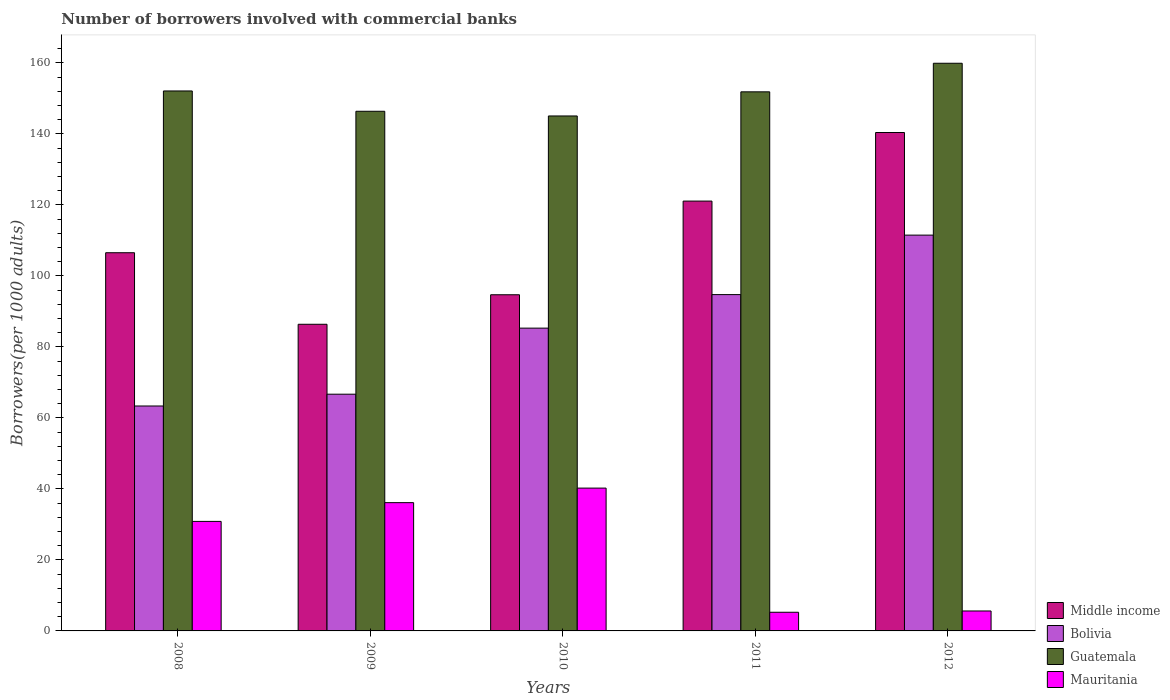Are the number of bars per tick equal to the number of legend labels?
Keep it short and to the point. Yes. Are the number of bars on each tick of the X-axis equal?
Your answer should be compact. Yes. How many bars are there on the 3rd tick from the left?
Your answer should be very brief. 4. How many bars are there on the 1st tick from the right?
Your answer should be very brief. 4. What is the label of the 2nd group of bars from the left?
Your response must be concise. 2009. What is the number of borrowers involved with commercial banks in Bolivia in 2009?
Offer a terse response. 66.68. Across all years, what is the maximum number of borrowers involved with commercial banks in Bolivia?
Provide a succinct answer. 111.49. Across all years, what is the minimum number of borrowers involved with commercial banks in Mauritania?
Give a very brief answer. 5.26. In which year was the number of borrowers involved with commercial banks in Bolivia maximum?
Ensure brevity in your answer.  2012. In which year was the number of borrowers involved with commercial banks in Middle income minimum?
Give a very brief answer. 2009. What is the total number of borrowers involved with commercial banks in Middle income in the graph?
Give a very brief answer. 549.05. What is the difference between the number of borrowers involved with commercial banks in Mauritania in 2009 and that in 2011?
Your response must be concise. 30.88. What is the difference between the number of borrowers involved with commercial banks in Middle income in 2008 and the number of borrowers involved with commercial banks in Mauritania in 2012?
Your answer should be compact. 100.91. What is the average number of borrowers involved with commercial banks in Bolivia per year?
Your answer should be compact. 84.31. In the year 2008, what is the difference between the number of borrowers involved with commercial banks in Guatemala and number of borrowers involved with commercial banks in Mauritania?
Make the answer very short. 121.25. What is the ratio of the number of borrowers involved with commercial banks in Guatemala in 2009 to that in 2010?
Provide a succinct answer. 1.01. What is the difference between the highest and the second highest number of borrowers involved with commercial banks in Middle income?
Keep it short and to the point. 19.32. What is the difference between the highest and the lowest number of borrowers involved with commercial banks in Bolivia?
Your response must be concise. 48.13. In how many years, is the number of borrowers involved with commercial banks in Guatemala greater than the average number of borrowers involved with commercial banks in Guatemala taken over all years?
Your answer should be very brief. 3. What does the 3rd bar from the left in 2012 represents?
Keep it short and to the point. Guatemala. What does the 1st bar from the right in 2012 represents?
Offer a terse response. Mauritania. What is the difference between two consecutive major ticks on the Y-axis?
Your answer should be very brief. 20. Does the graph contain grids?
Your answer should be compact. No. Where does the legend appear in the graph?
Give a very brief answer. Bottom right. How are the legend labels stacked?
Provide a succinct answer. Vertical. What is the title of the graph?
Provide a succinct answer. Number of borrowers involved with commercial banks. What is the label or title of the Y-axis?
Offer a very short reply. Borrowers(per 1000 adults). What is the Borrowers(per 1000 adults) in Middle income in 2008?
Keep it short and to the point. 106.53. What is the Borrowers(per 1000 adults) in Bolivia in 2008?
Your answer should be compact. 63.36. What is the Borrowers(per 1000 adults) in Guatemala in 2008?
Provide a short and direct response. 152.09. What is the Borrowers(per 1000 adults) in Mauritania in 2008?
Your response must be concise. 30.85. What is the Borrowers(per 1000 adults) in Middle income in 2009?
Your answer should be very brief. 86.38. What is the Borrowers(per 1000 adults) of Bolivia in 2009?
Ensure brevity in your answer.  66.68. What is the Borrowers(per 1000 adults) in Guatemala in 2009?
Provide a succinct answer. 146.37. What is the Borrowers(per 1000 adults) of Mauritania in 2009?
Your answer should be compact. 36.13. What is the Borrowers(per 1000 adults) in Middle income in 2010?
Give a very brief answer. 94.69. What is the Borrowers(per 1000 adults) in Bolivia in 2010?
Your answer should be compact. 85.29. What is the Borrowers(per 1000 adults) in Guatemala in 2010?
Give a very brief answer. 145.05. What is the Borrowers(per 1000 adults) of Mauritania in 2010?
Give a very brief answer. 40.23. What is the Borrowers(per 1000 adults) of Middle income in 2011?
Offer a very short reply. 121.07. What is the Borrowers(per 1000 adults) of Bolivia in 2011?
Provide a short and direct response. 94.73. What is the Borrowers(per 1000 adults) of Guatemala in 2011?
Provide a short and direct response. 151.85. What is the Borrowers(per 1000 adults) in Mauritania in 2011?
Your response must be concise. 5.26. What is the Borrowers(per 1000 adults) of Middle income in 2012?
Give a very brief answer. 140.39. What is the Borrowers(per 1000 adults) in Bolivia in 2012?
Keep it short and to the point. 111.49. What is the Borrowers(per 1000 adults) in Guatemala in 2012?
Your answer should be very brief. 159.9. What is the Borrowers(per 1000 adults) in Mauritania in 2012?
Your answer should be very brief. 5.62. Across all years, what is the maximum Borrowers(per 1000 adults) in Middle income?
Your answer should be compact. 140.39. Across all years, what is the maximum Borrowers(per 1000 adults) of Bolivia?
Your answer should be very brief. 111.49. Across all years, what is the maximum Borrowers(per 1000 adults) in Guatemala?
Offer a terse response. 159.9. Across all years, what is the maximum Borrowers(per 1000 adults) in Mauritania?
Your answer should be compact. 40.23. Across all years, what is the minimum Borrowers(per 1000 adults) of Middle income?
Your answer should be compact. 86.38. Across all years, what is the minimum Borrowers(per 1000 adults) in Bolivia?
Ensure brevity in your answer.  63.36. Across all years, what is the minimum Borrowers(per 1000 adults) of Guatemala?
Your response must be concise. 145.05. Across all years, what is the minimum Borrowers(per 1000 adults) of Mauritania?
Provide a succinct answer. 5.26. What is the total Borrowers(per 1000 adults) in Middle income in the graph?
Offer a very short reply. 549.05. What is the total Borrowers(per 1000 adults) of Bolivia in the graph?
Your response must be concise. 421.54. What is the total Borrowers(per 1000 adults) in Guatemala in the graph?
Provide a short and direct response. 755.26. What is the total Borrowers(per 1000 adults) in Mauritania in the graph?
Your answer should be compact. 118.08. What is the difference between the Borrowers(per 1000 adults) of Middle income in 2008 and that in 2009?
Ensure brevity in your answer.  20.15. What is the difference between the Borrowers(per 1000 adults) of Bolivia in 2008 and that in 2009?
Offer a very short reply. -3.32. What is the difference between the Borrowers(per 1000 adults) of Guatemala in 2008 and that in 2009?
Ensure brevity in your answer.  5.72. What is the difference between the Borrowers(per 1000 adults) in Mauritania in 2008 and that in 2009?
Offer a terse response. -5.28. What is the difference between the Borrowers(per 1000 adults) in Middle income in 2008 and that in 2010?
Your response must be concise. 11.84. What is the difference between the Borrowers(per 1000 adults) in Bolivia in 2008 and that in 2010?
Give a very brief answer. -21.93. What is the difference between the Borrowers(per 1000 adults) of Guatemala in 2008 and that in 2010?
Your answer should be very brief. 7.04. What is the difference between the Borrowers(per 1000 adults) in Mauritania in 2008 and that in 2010?
Your response must be concise. -9.38. What is the difference between the Borrowers(per 1000 adults) in Middle income in 2008 and that in 2011?
Make the answer very short. -14.55. What is the difference between the Borrowers(per 1000 adults) in Bolivia in 2008 and that in 2011?
Offer a very short reply. -31.37. What is the difference between the Borrowers(per 1000 adults) of Guatemala in 2008 and that in 2011?
Your answer should be very brief. 0.25. What is the difference between the Borrowers(per 1000 adults) of Mauritania in 2008 and that in 2011?
Make the answer very short. 25.59. What is the difference between the Borrowers(per 1000 adults) in Middle income in 2008 and that in 2012?
Keep it short and to the point. -33.86. What is the difference between the Borrowers(per 1000 adults) in Bolivia in 2008 and that in 2012?
Your response must be concise. -48.13. What is the difference between the Borrowers(per 1000 adults) in Guatemala in 2008 and that in 2012?
Offer a terse response. -7.8. What is the difference between the Borrowers(per 1000 adults) in Mauritania in 2008 and that in 2012?
Give a very brief answer. 25.23. What is the difference between the Borrowers(per 1000 adults) of Middle income in 2009 and that in 2010?
Provide a short and direct response. -8.31. What is the difference between the Borrowers(per 1000 adults) of Bolivia in 2009 and that in 2010?
Offer a very short reply. -18.61. What is the difference between the Borrowers(per 1000 adults) of Guatemala in 2009 and that in 2010?
Provide a short and direct response. 1.32. What is the difference between the Borrowers(per 1000 adults) of Mauritania in 2009 and that in 2010?
Give a very brief answer. -4.1. What is the difference between the Borrowers(per 1000 adults) in Middle income in 2009 and that in 2011?
Your answer should be very brief. -34.7. What is the difference between the Borrowers(per 1000 adults) in Bolivia in 2009 and that in 2011?
Ensure brevity in your answer.  -28.05. What is the difference between the Borrowers(per 1000 adults) in Guatemala in 2009 and that in 2011?
Your answer should be very brief. -5.48. What is the difference between the Borrowers(per 1000 adults) in Mauritania in 2009 and that in 2011?
Offer a terse response. 30.88. What is the difference between the Borrowers(per 1000 adults) of Middle income in 2009 and that in 2012?
Offer a very short reply. -54.02. What is the difference between the Borrowers(per 1000 adults) in Bolivia in 2009 and that in 2012?
Give a very brief answer. -44.81. What is the difference between the Borrowers(per 1000 adults) of Guatemala in 2009 and that in 2012?
Ensure brevity in your answer.  -13.53. What is the difference between the Borrowers(per 1000 adults) of Mauritania in 2009 and that in 2012?
Keep it short and to the point. 30.51. What is the difference between the Borrowers(per 1000 adults) in Middle income in 2010 and that in 2011?
Offer a very short reply. -26.38. What is the difference between the Borrowers(per 1000 adults) in Bolivia in 2010 and that in 2011?
Keep it short and to the point. -9.45. What is the difference between the Borrowers(per 1000 adults) of Guatemala in 2010 and that in 2011?
Keep it short and to the point. -6.8. What is the difference between the Borrowers(per 1000 adults) of Mauritania in 2010 and that in 2011?
Your response must be concise. 34.97. What is the difference between the Borrowers(per 1000 adults) in Middle income in 2010 and that in 2012?
Your answer should be compact. -45.7. What is the difference between the Borrowers(per 1000 adults) of Bolivia in 2010 and that in 2012?
Give a very brief answer. -26.2. What is the difference between the Borrowers(per 1000 adults) in Guatemala in 2010 and that in 2012?
Your answer should be compact. -14.85. What is the difference between the Borrowers(per 1000 adults) of Mauritania in 2010 and that in 2012?
Your answer should be compact. 34.61. What is the difference between the Borrowers(per 1000 adults) of Middle income in 2011 and that in 2012?
Offer a terse response. -19.32. What is the difference between the Borrowers(per 1000 adults) of Bolivia in 2011 and that in 2012?
Ensure brevity in your answer.  -16.75. What is the difference between the Borrowers(per 1000 adults) in Guatemala in 2011 and that in 2012?
Make the answer very short. -8.05. What is the difference between the Borrowers(per 1000 adults) in Mauritania in 2011 and that in 2012?
Give a very brief answer. -0.36. What is the difference between the Borrowers(per 1000 adults) in Middle income in 2008 and the Borrowers(per 1000 adults) in Bolivia in 2009?
Offer a terse response. 39.85. What is the difference between the Borrowers(per 1000 adults) in Middle income in 2008 and the Borrowers(per 1000 adults) in Guatemala in 2009?
Your answer should be very brief. -39.85. What is the difference between the Borrowers(per 1000 adults) in Middle income in 2008 and the Borrowers(per 1000 adults) in Mauritania in 2009?
Your answer should be very brief. 70.39. What is the difference between the Borrowers(per 1000 adults) in Bolivia in 2008 and the Borrowers(per 1000 adults) in Guatemala in 2009?
Give a very brief answer. -83.01. What is the difference between the Borrowers(per 1000 adults) in Bolivia in 2008 and the Borrowers(per 1000 adults) in Mauritania in 2009?
Offer a very short reply. 27.23. What is the difference between the Borrowers(per 1000 adults) of Guatemala in 2008 and the Borrowers(per 1000 adults) of Mauritania in 2009?
Give a very brief answer. 115.96. What is the difference between the Borrowers(per 1000 adults) of Middle income in 2008 and the Borrowers(per 1000 adults) of Bolivia in 2010?
Keep it short and to the point. 21.24. What is the difference between the Borrowers(per 1000 adults) in Middle income in 2008 and the Borrowers(per 1000 adults) in Guatemala in 2010?
Make the answer very short. -38.52. What is the difference between the Borrowers(per 1000 adults) in Middle income in 2008 and the Borrowers(per 1000 adults) in Mauritania in 2010?
Your response must be concise. 66.3. What is the difference between the Borrowers(per 1000 adults) of Bolivia in 2008 and the Borrowers(per 1000 adults) of Guatemala in 2010?
Offer a very short reply. -81.69. What is the difference between the Borrowers(per 1000 adults) of Bolivia in 2008 and the Borrowers(per 1000 adults) of Mauritania in 2010?
Keep it short and to the point. 23.13. What is the difference between the Borrowers(per 1000 adults) of Guatemala in 2008 and the Borrowers(per 1000 adults) of Mauritania in 2010?
Your response must be concise. 111.86. What is the difference between the Borrowers(per 1000 adults) in Middle income in 2008 and the Borrowers(per 1000 adults) in Bolivia in 2011?
Offer a terse response. 11.79. What is the difference between the Borrowers(per 1000 adults) of Middle income in 2008 and the Borrowers(per 1000 adults) of Guatemala in 2011?
Give a very brief answer. -45.32. What is the difference between the Borrowers(per 1000 adults) in Middle income in 2008 and the Borrowers(per 1000 adults) in Mauritania in 2011?
Offer a very short reply. 101.27. What is the difference between the Borrowers(per 1000 adults) of Bolivia in 2008 and the Borrowers(per 1000 adults) of Guatemala in 2011?
Provide a succinct answer. -88.49. What is the difference between the Borrowers(per 1000 adults) in Bolivia in 2008 and the Borrowers(per 1000 adults) in Mauritania in 2011?
Your answer should be very brief. 58.1. What is the difference between the Borrowers(per 1000 adults) in Guatemala in 2008 and the Borrowers(per 1000 adults) in Mauritania in 2011?
Keep it short and to the point. 146.84. What is the difference between the Borrowers(per 1000 adults) of Middle income in 2008 and the Borrowers(per 1000 adults) of Bolivia in 2012?
Your answer should be compact. -4.96. What is the difference between the Borrowers(per 1000 adults) in Middle income in 2008 and the Borrowers(per 1000 adults) in Guatemala in 2012?
Offer a very short reply. -53.37. What is the difference between the Borrowers(per 1000 adults) in Middle income in 2008 and the Borrowers(per 1000 adults) in Mauritania in 2012?
Offer a very short reply. 100.91. What is the difference between the Borrowers(per 1000 adults) in Bolivia in 2008 and the Borrowers(per 1000 adults) in Guatemala in 2012?
Offer a very short reply. -96.54. What is the difference between the Borrowers(per 1000 adults) in Bolivia in 2008 and the Borrowers(per 1000 adults) in Mauritania in 2012?
Offer a very short reply. 57.74. What is the difference between the Borrowers(per 1000 adults) of Guatemala in 2008 and the Borrowers(per 1000 adults) of Mauritania in 2012?
Offer a very short reply. 146.48. What is the difference between the Borrowers(per 1000 adults) of Middle income in 2009 and the Borrowers(per 1000 adults) of Bolivia in 2010?
Offer a terse response. 1.09. What is the difference between the Borrowers(per 1000 adults) of Middle income in 2009 and the Borrowers(per 1000 adults) of Guatemala in 2010?
Provide a succinct answer. -58.68. What is the difference between the Borrowers(per 1000 adults) of Middle income in 2009 and the Borrowers(per 1000 adults) of Mauritania in 2010?
Ensure brevity in your answer.  46.15. What is the difference between the Borrowers(per 1000 adults) in Bolivia in 2009 and the Borrowers(per 1000 adults) in Guatemala in 2010?
Offer a terse response. -78.37. What is the difference between the Borrowers(per 1000 adults) of Bolivia in 2009 and the Borrowers(per 1000 adults) of Mauritania in 2010?
Make the answer very short. 26.45. What is the difference between the Borrowers(per 1000 adults) in Guatemala in 2009 and the Borrowers(per 1000 adults) in Mauritania in 2010?
Your answer should be very brief. 106.14. What is the difference between the Borrowers(per 1000 adults) of Middle income in 2009 and the Borrowers(per 1000 adults) of Bolivia in 2011?
Ensure brevity in your answer.  -8.36. What is the difference between the Borrowers(per 1000 adults) in Middle income in 2009 and the Borrowers(per 1000 adults) in Guatemala in 2011?
Your response must be concise. -65.47. What is the difference between the Borrowers(per 1000 adults) of Middle income in 2009 and the Borrowers(per 1000 adults) of Mauritania in 2011?
Your answer should be very brief. 81.12. What is the difference between the Borrowers(per 1000 adults) of Bolivia in 2009 and the Borrowers(per 1000 adults) of Guatemala in 2011?
Ensure brevity in your answer.  -85.17. What is the difference between the Borrowers(per 1000 adults) in Bolivia in 2009 and the Borrowers(per 1000 adults) in Mauritania in 2011?
Your answer should be compact. 61.42. What is the difference between the Borrowers(per 1000 adults) of Guatemala in 2009 and the Borrowers(per 1000 adults) of Mauritania in 2011?
Keep it short and to the point. 141.11. What is the difference between the Borrowers(per 1000 adults) of Middle income in 2009 and the Borrowers(per 1000 adults) of Bolivia in 2012?
Provide a succinct answer. -25.11. What is the difference between the Borrowers(per 1000 adults) of Middle income in 2009 and the Borrowers(per 1000 adults) of Guatemala in 2012?
Keep it short and to the point. -73.52. What is the difference between the Borrowers(per 1000 adults) in Middle income in 2009 and the Borrowers(per 1000 adults) in Mauritania in 2012?
Give a very brief answer. 80.76. What is the difference between the Borrowers(per 1000 adults) of Bolivia in 2009 and the Borrowers(per 1000 adults) of Guatemala in 2012?
Make the answer very short. -93.22. What is the difference between the Borrowers(per 1000 adults) in Bolivia in 2009 and the Borrowers(per 1000 adults) in Mauritania in 2012?
Ensure brevity in your answer.  61.06. What is the difference between the Borrowers(per 1000 adults) in Guatemala in 2009 and the Borrowers(per 1000 adults) in Mauritania in 2012?
Provide a short and direct response. 140.75. What is the difference between the Borrowers(per 1000 adults) of Middle income in 2010 and the Borrowers(per 1000 adults) of Bolivia in 2011?
Give a very brief answer. -0.04. What is the difference between the Borrowers(per 1000 adults) of Middle income in 2010 and the Borrowers(per 1000 adults) of Guatemala in 2011?
Give a very brief answer. -57.16. What is the difference between the Borrowers(per 1000 adults) of Middle income in 2010 and the Borrowers(per 1000 adults) of Mauritania in 2011?
Offer a terse response. 89.43. What is the difference between the Borrowers(per 1000 adults) in Bolivia in 2010 and the Borrowers(per 1000 adults) in Guatemala in 2011?
Your answer should be very brief. -66.56. What is the difference between the Borrowers(per 1000 adults) in Bolivia in 2010 and the Borrowers(per 1000 adults) in Mauritania in 2011?
Offer a very short reply. 80.03. What is the difference between the Borrowers(per 1000 adults) in Guatemala in 2010 and the Borrowers(per 1000 adults) in Mauritania in 2011?
Provide a succinct answer. 139.79. What is the difference between the Borrowers(per 1000 adults) in Middle income in 2010 and the Borrowers(per 1000 adults) in Bolivia in 2012?
Ensure brevity in your answer.  -16.8. What is the difference between the Borrowers(per 1000 adults) in Middle income in 2010 and the Borrowers(per 1000 adults) in Guatemala in 2012?
Your answer should be very brief. -65.21. What is the difference between the Borrowers(per 1000 adults) in Middle income in 2010 and the Borrowers(per 1000 adults) in Mauritania in 2012?
Your answer should be compact. 89.07. What is the difference between the Borrowers(per 1000 adults) of Bolivia in 2010 and the Borrowers(per 1000 adults) of Guatemala in 2012?
Ensure brevity in your answer.  -74.61. What is the difference between the Borrowers(per 1000 adults) of Bolivia in 2010 and the Borrowers(per 1000 adults) of Mauritania in 2012?
Keep it short and to the point. 79.67. What is the difference between the Borrowers(per 1000 adults) in Guatemala in 2010 and the Borrowers(per 1000 adults) in Mauritania in 2012?
Offer a terse response. 139.43. What is the difference between the Borrowers(per 1000 adults) in Middle income in 2011 and the Borrowers(per 1000 adults) in Bolivia in 2012?
Give a very brief answer. 9.59. What is the difference between the Borrowers(per 1000 adults) of Middle income in 2011 and the Borrowers(per 1000 adults) of Guatemala in 2012?
Keep it short and to the point. -38.82. What is the difference between the Borrowers(per 1000 adults) of Middle income in 2011 and the Borrowers(per 1000 adults) of Mauritania in 2012?
Offer a very short reply. 115.45. What is the difference between the Borrowers(per 1000 adults) of Bolivia in 2011 and the Borrowers(per 1000 adults) of Guatemala in 2012?
Your response must be concise. -65.16. What is the difference between the Borrowers(per 1000 adults) in Bolivia in 2011 and the Borrowers(per 1000 adults) in Mauritania in 2012?
Provide a succinct answer. 89.11. What is the difference between the Borrowers(per 1000 adults) in Guatemala in 2011 and the Borrowers(per 1000 adults) in Mauritania in 2012?
Offer a terse response. 146.23. What is the average Borrowers(per 1000 adults) in Middle income per year?
Offer a terse response. 109.81. What is the average Borrowers(per 1000 adults) of Bolivia per year?
Your answer should be very brief. 84.31. What is the average Borrowers(per 1000 adults) of Guatemala per year?
Keep it short and to the point. 151.05. What is the average Borrowers(per 1000 adults) of Mauritania per year?
Your answer should be very brief. 23.62. In the year 2008, what is the difference between the Borrowers(per 1000 adults) of Middle income and Borrowers(per 1000 adults) of Bolivia?
Ensure brevity in your answer.  43.17. In the year 2008, what is the difference between the Borrowers(per 1000 adults) in Middle income and Borrowers(per 1000 adults) in Guatemala?
Your answer should be compact. -45.57. In the year 2008, what is the difference between the Borrowers(per 1000 adults) of Middle income and Borrowers(per 1000 adults) of Mauritania?
Provide a short and direct response. 75.68. In the year 2008, what is the difference between the Borrowers(per 1000 adults) in Bolivia and Borrowers(per 1000 adults) in Guatemala?
Provide a short and direct response. -88.74. In the year 2008, what is the difference between the Borrowers(per 1000 adults) of Bolivia and Borrowers(per 1000 adults) of Mauritania?
Your answer should be compact. 32.51. In the year 2008, what is the difference between the Borrowers(per 1000 adults) in Guatemala and Borrowers(per 1000 adults) in Mauritania?
Make the answer very short. 121.25. In the year 2009, what is the difference between the Borrowers(per 1000 adults) of Middle income and Borrowers(per 1000 adults) of Bolivia?
Offer a very short reply. 19.7. In the year 2009, what is the difference between the Borrowers(per 1000 adults) in Middle income and Borrowers(per 1000 adults) in Guatemala?
Provide a succinct answer. -60. In the year 2009, what is the difference between the Borrowers(per 1000 adults) in Middle income and Borrowers(per 1000 adults) in Mauritania?
Provide a succinct answer. 50.24. In the year 2009, what is the difference between the Borrowers(per 1000 adults) of Bolivia and Borrowers(per 1000 adults) of Guatemala?
Give a very brief answer. -79.69. In the year 2009, what is the difference between the Borrowers(per 1000 adults) of Bolivia and Borrowers(per 1000 adults) of Mauritania?
Make the answer very short. 30.55. In the year 2009, what is the difference between the Borrowers(per 1000 adults) of Guatemala and Borrowers(per 1000 adults) of Mauritania?
Provide a succinct answer. 110.24. In the year 2010, what is the difference between the Borrowers(per 1000 adults) of Middle income and Borrowers(per 1000 adults) of Bolivia?
Provide a short and direct response. 9.4. In the year 2010, what is the difference between the Borrowers(per 1000 adults) in Middle income and Borrowers(per 1000 adults) in Guatemala?
Your answer should be very brief. -50.36. In the year 2010, what is the difference between the Borrowers(per 1000 adults) in Middle income and Borrowers(per 1000 adults) in Mauritania?
Keep it short and to the point. 54.46. In the year 2010, what is the difference between the Borrowers(per 1000 adults) of Bolivia and Borrowers(per 1000 adults) of Guatemala?
Your response must be concise. -59.76. In the year 2010, what is the difference between the Borrowers(per 1000 adults) in Bolivia and Borrowers(per 1000 adults) in Mauritania?
Offer a very short reply. 45.06. In the year 2010, what is the difference between the Borrowers(per 1000 adults) in Guatemala and Borrowers(per 1000 adults) in Mauritania?
Offer a terse response. 104.82. In the year 2011, what is the difference between the Borrowers(per 1000 adults) in Middle income and Borrowers(per 1000 adults) in Bolivia?
Give a very brief answer. 26.34. In the year 2011, what is the difference between the Borrowers(per 1000 adults) of Middle income and Borrowers(per 1000 adults) of Guatemala?
Your answer should be compact. -30.78. In the year 2011, what is the difference between the Borrowers(per 1000 adults) in Middle income and Borrowers(per 1000 adults) in Mauritania?
Offer a terse response. 115.82. In the year 2011, what is the difference between the Borrowers(per 1000 adults) of Bolivia and Borrowers(per 1000 adults) of Guatemala?
Give a very brief answer. -57.12. In the year 2011, what is the difference between the Borrowers(per 1000 adults) in Bolivia and Borrowers(per 1000 adults) in Mauritania?
Provide a succinct answer. 89.48. In the year 2011, what is the difference between the Borrowers(per 1000 adults) in Guatemala and Borrowers(per 1000 adults) in Mauritania?
Your answer should be compact. 146.59. In the year 2012, what is the difference between the Borrowers(per 1000 adults) in Middle income and Borrowers(per 1000 adults) in Bolivia?
Make the answer very short. 28.9. In the year 2012, what is the difference between the Borrowers(per 1000 adults) of Middle income and Borrowers(per 1000 adults) of Guatemala?
Offer a terse response. -19.51. In the year 2012, what is the difference between the Borrowers(per 1000 adults) in Middle income and Borrowers(per 1000 adults) in Mauritania?
Your answer should be compact. 134.77. In the year 2012, what is the difference between the Borrowers(per 1000 adults) in Bolivia and Borrowers(per 1000 adults) in Guatemala?
Your answer should be compact. -48.41. In the year 2012, what is the difference between the Borrowers(per 1000 adults) in Bolivia and Borrowers(per 1000 adults) in Mauritania?
Keep it short and to the point. 105.87. In the year 2012, what is the difference between the Borrowers(per 1000 adults) of Guatemala and Borrowers(per 1000 adults) of Mauritania?
Offer a very short reply. 154.28. What is the ratio of the Borrowers(per 1000 adults) in Middle income in 2008 to that in 2009?
Your answer should be very brief. 1.23. What is the ratio of the Borrowers(per 1000 adults) in Bolivia in 2008 to that in 2009?
Provide a short and direct response. 0.95. What is the ratio of the Borrowers(per 1000 adults) of Guatemala in 2008 to that in 2009?
Provide a short and direct response. 1.04. What is the ratio of the Borrowers(per 1000 adults) of Mauritania in 2008 to that in 2009?
Ensure brevity in your answer.  0.85. What is the ratio of the Borrowers(per 1000 adults) in Middle income in 2008 to that in 2010?
Offer a terse response. 1.12. What is the ratio of the Borrowers(per 1000 adults) in Bolivia in 2008 to that in 2010?
Ensure brevity in your answer.  0.74. What is the ratio of the Borrowers(per 1000 adults) in Guatemala in 2008 to that in 2010?
Keep it short and to the point. 1.05. What is the ratio of the Borrowers(per 1000 adults) in Mauritania in 2008 to that in 2010?
Offer a terse response. 0.77. What is the ratio of the Borrowers(per 1000 adults) in Middle income in 2008 to that in 2011?
Provide a succinct answer. 0.88. What is the ratio of the Borrowers(per 1000 adults) in Bolivia in 2008 to that in 2011?
Make the answer very short. 0.67. What is the ratio of the Borrowers(per 1000 adults) in Mauritania in 2008 to that in 2011?
Make the answer very short. 5.87. What is the ratio of the Borrowers(per 1000 adults) in Middle income in 2008 to that in 2012?
Keep it short and to the point. 0.76. What is the ratio of the Borrowers(per 1000 adults) of Bolivia in 2008 to that in 2012?
Provide a succinct answer. 0.57. What is the ratio of the Borrowers(per 1000 adults) of Guatemala in 2008 to that in 2012?
Provide a short and direct response. 0.95. What is the ratio of the Borrowers(per 1000 adults) of Mauritania in 2008 to that in 2012?
Give a very brief answer. 5.49. What is the ratio of the Borrowers(per 1000 adults) of Middle income in 2009 to that in 2010?
Your answer should be very brief. 0.91. What is the ratio of the Borrowers(per 1000 adults) in Bolivia in 2009 to that in 2010?
Make the answer very short. 0.78. What is the ratio of the Borrowers(per 1000 adults) of Guatemala in 2009 to that in 2010?
Ensure brevity in your answer.  1.01. What is the ratio of the Borrowers(per 1000 adults) in Mauritania in 2009 to that in 2010?
Your answer should be compact. 0.9. What is the ratio of the Borrowers(per 1000 adults) of Middle income in 2009 to that in 2011?
Keep it short and to the point. 0.71. What is the ratio of the Borrowers(per 1000 adults) in Bolivia in 2009 to that in 2011?
Offer a terse response. 0.7. What is the ratio of the Borrowers(per 1000 adults) in Guatemala in 2009 to that in 2011?
Ensure brevity in your answer.  0.96. What is the ratio of the Borrowers(per 1000 adults) in Mauritania in 2009 to that in 2011?
Provide a short and direct response. 6.87. What is the ratio of the Borrowers(per 1000 adults) in Middle income in 2009 to that in 2012?
Offer a terse response. 0.62. What is the ratio of the Borrowers(per 1000 adults) in Bolivia in 2009 to that in 2012?
Offer a very short reply. 0.6. What is the ratio of the Borrowers(per 1000 adults) in Guatemala in 2009 to that in 2012?
Offer a very short reply. 0.92. What is the ratio of the Borrowers(per 1000 adults) in Mauritania in 2009 to that in 2012?
Offer a terse response. 6.43. What is the ratio of the Borrowers(per 1000 adults) of Middle income in 2010 to that in 2011?
Provide a succinct answer. 0.78. What is the ratio of the Borrowers(per 1000 adults) of Bolivia in 2010 to that in 2011?
Your response must be concise. 0.9. What is the ratio of the Borrowers(per 1000 adults) of Guatemala in 2010 to that in 2011?
Your response must be concise. 0.96. What is the ratio of the Borrowers(per 1000 adults) of Mauritania in 2010 to that in 2011?
Provide a short and direct response. 7.65. What is the ratio of the Borrowers(per 1000 adults) of Middle income in 2010 to that in 2012?
Keep it short and to the point. 0.67. What is the ratio of the Borrowers(per 1000 adults) of Bolivia in 2010 to that in 2012?
Your answer should be very brief. 0.77. What is the ratio of the Borrowers(per 1000 adults) of Guatemala in 2010 to that in 2012?
Your response must be concise. 0.91. What is the ratio of the Borrowers(per 1000 adults) of Mauritania in 2010 to that in 2012?
Make the answer very short. 7.16. What is the ratio of the Borrowers(per 1000 adults) in Middle income in 2011 to that in 2012?
Your answer should be compact. 0.86. What is the ratio of the Borrowers(per 1000 adults) in Bolivia in 2011 to that in 2012?
Your answer should be compact. 0.85. What is the ratio of the Borrowers(per 1000 adults) of Guatemala in 2011 to that in 2012?
Offer a very short reply. 0.95. What is the ratio of the Borrowers(per 1000 adults) of Mauritania in 2011 to that in 2012?
Your response must be concise. 0.94. What is the difference between the highest and the second highest Borrowers(per 1000 adults) in Middle income?
Make the answer very short. 19.32. What is the difference between the highest and the second highest Borrowers(per 1000 adults) of Bolivia?
Make the answer very short. 16.75. What is the difference between the highest and the second highest Borrowers(per 1000 adults) of Guatemala?
Provide a short and direct response. 7.8. What is the difference between the highest and the second highest Borrowers(per 1000 adults) in Mauritania?
Keep it short and to the point. 4.1. What is the difference between the highest and the lowest Borrowers(per 1000 adults) in Middle income?
Your answer should be very brief. 54.02. What is the difference between the highest and the lowest Borrowers(per 1000 adults) of Bolivia?
Your answer should be compact. 48.13. What is the difference between the highest and the lowest Borrowers(per 1000 adults) in Guatemala?
Your answer should be compact. 14.85. What is the difference between the highest and the lowest Borrowers(per 1000 adults) of Mauritania?
Give a very brief answer. 34.97. 